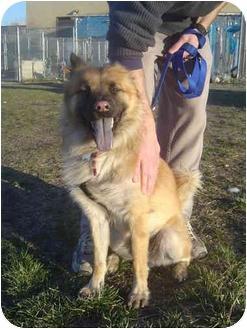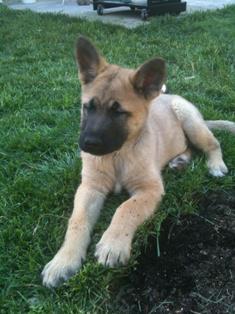The first image is the image on the left, the second image is the image on the right. For the images displayed, is the sentence "One dog with a dark muzzle is reclining on the grass, and at least one dog has an opened, non-snarling mouth." factually correct? Answer yes or no. Yes. The first image is the image on the left, the second image is the image on the right. Examine the images to the left and right. Is the description "There is a human touching one of the dogs." accurate? Answer yes or no. Yes. 